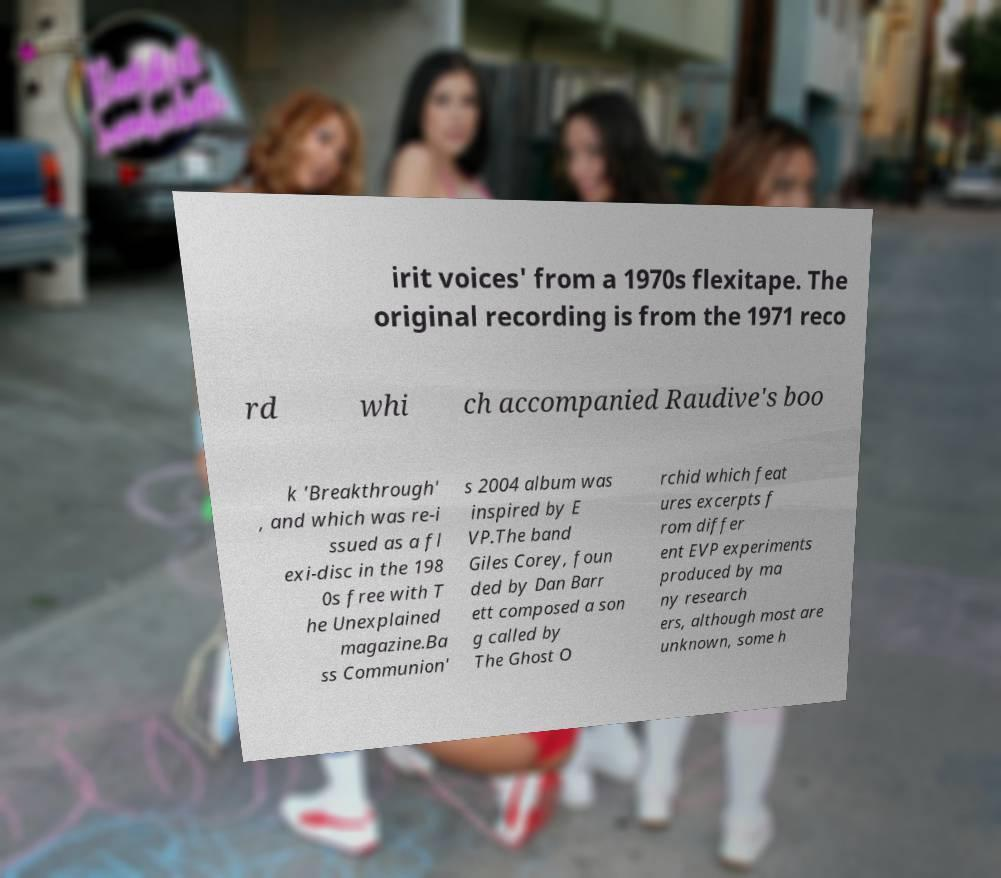I need the written content from this picture converted into text. Can you do that? irit voices' from a 1970s flexitape. The original recording is from the 1971 reco rd whi ch accompanied Raudive's boo k 'Breakthrough' , and which was re-i ssued as a fl exi-disc in the 198 0s free with T he Unexplained magazine.Ba ss Communion' s 2004 album was inspired by E VP.The band Giles Corey, foun ded by Dan Barr ett composed a son g called by The Ghost O rchid which feat ures excerpts f rom differ ent EVP experiments produced by ma ny research ers, although most are unknown, some h 